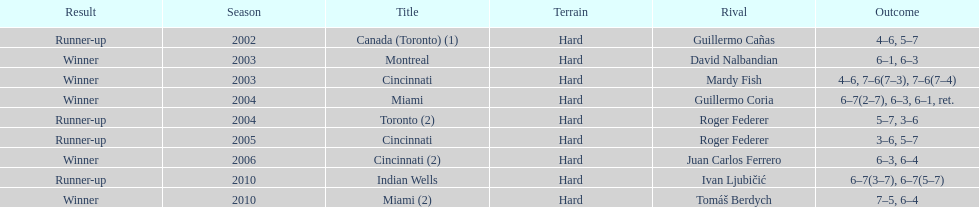How many consecutive years was there a hard surface at the championship? 9. 